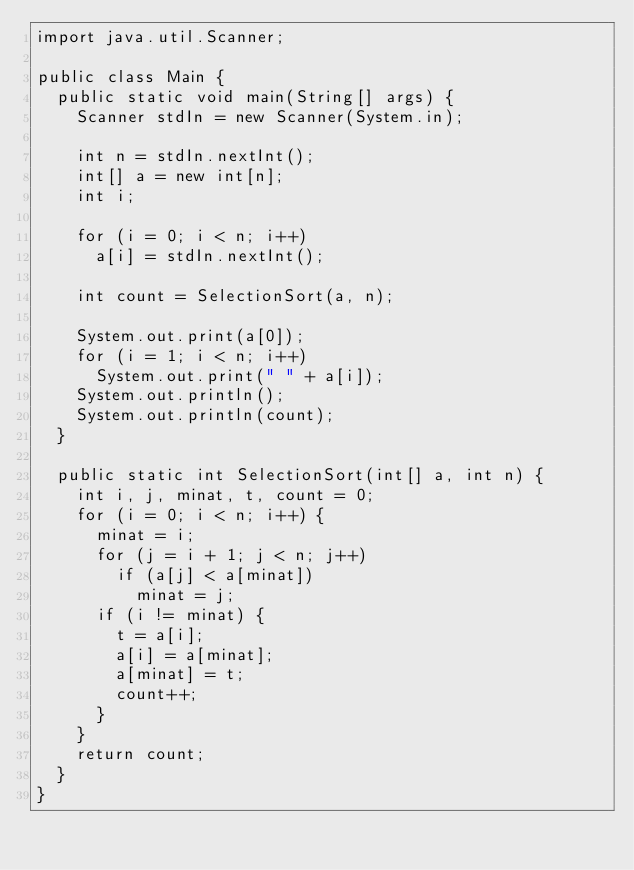Convert code to text. <code><loc_0><loc_0><loc_500><loc_500><_Java_>import java.util.Scanner;

public class Main {
	public static void main(String[] args) {
		Scanner stdIn = new Scanner(System.in);
		
		int n = stdIn.nextInt();
		int[] a = new int[n];
		int i;
		
		for (i = 0; i < n; i++)
			a[i] = stdIn.nextInt();
		
		int count = SelectionSort(a, n);
		
		System.out.print(a[0]);
		for (i = 1; i < n; i++)
			System.out.print(" " + a[i]);
		System.out.println();
		System.out.println(count);
	}
	
	public static int SelectionSort(int[] a, int n) {
		int i, j, minat, t, count = 0;
		for (i = 0; i < n; i++) {
			minat = i;
			for (j = i + 1; j < n; j++)
				if (a[j] < a[minat])
					minat = j;
			if (i != minat) {
				t = a[i];
				a[i] = a[minat];
				a[minat] = t;
				count++;
			}
		}
		return count;
	}
}</code> 